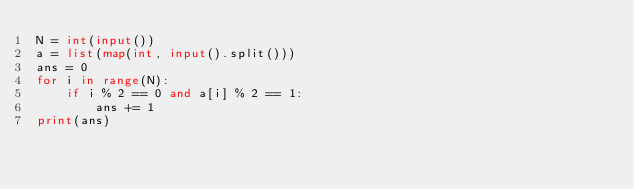<code> <loc_0><loc_0><loc_500><loc_500><_Python_>N = int(input())
a = list(map(int, input().split()))
ans = 0
for i in range(N):
    if i % 2 == 0 and a[i] % 2 == 1:
        ans += 1
print(ans)</code> 